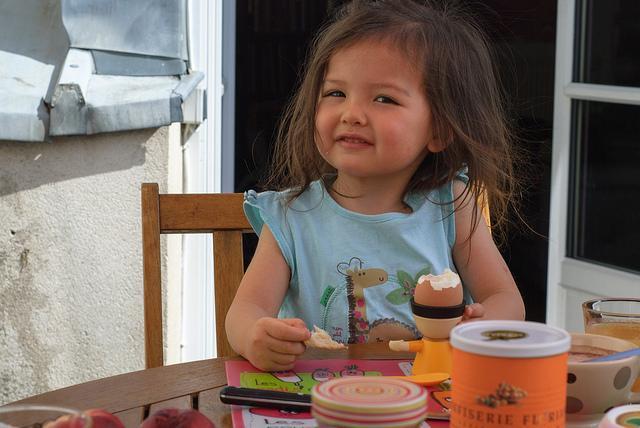Is the caption "The person is at the back of the dining table." a true representation of the image?
Answer yes or no. Yes. 